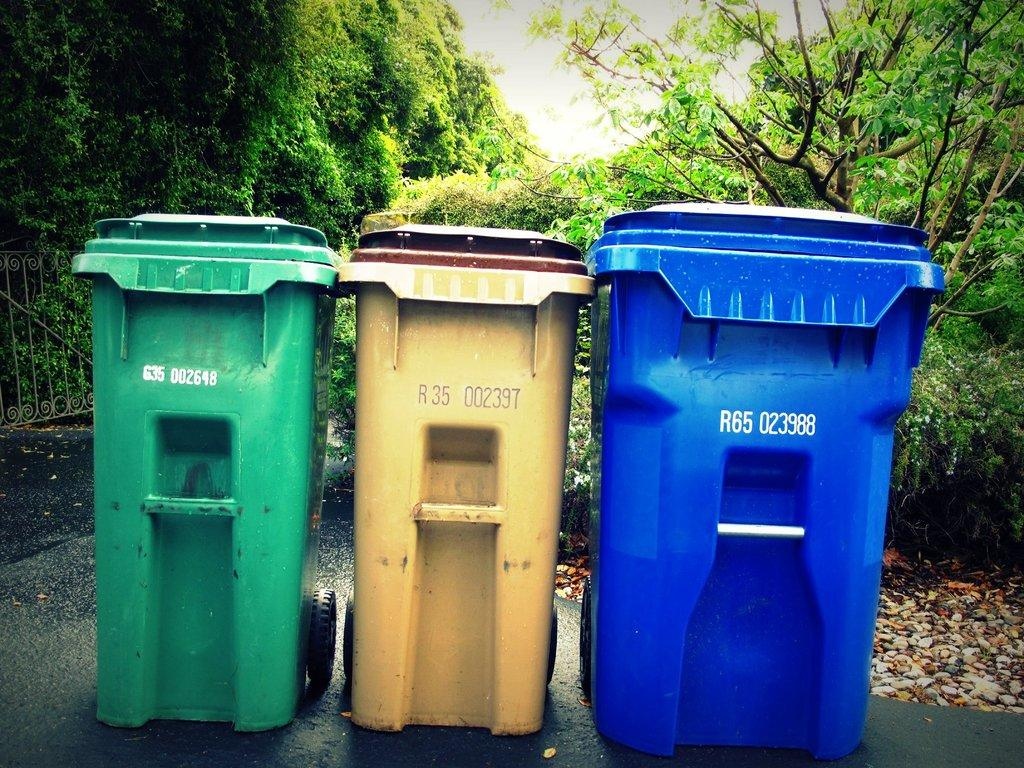<image>
Give a short and clear explanation of the subsequent image. the number 65 is on the blue bin 